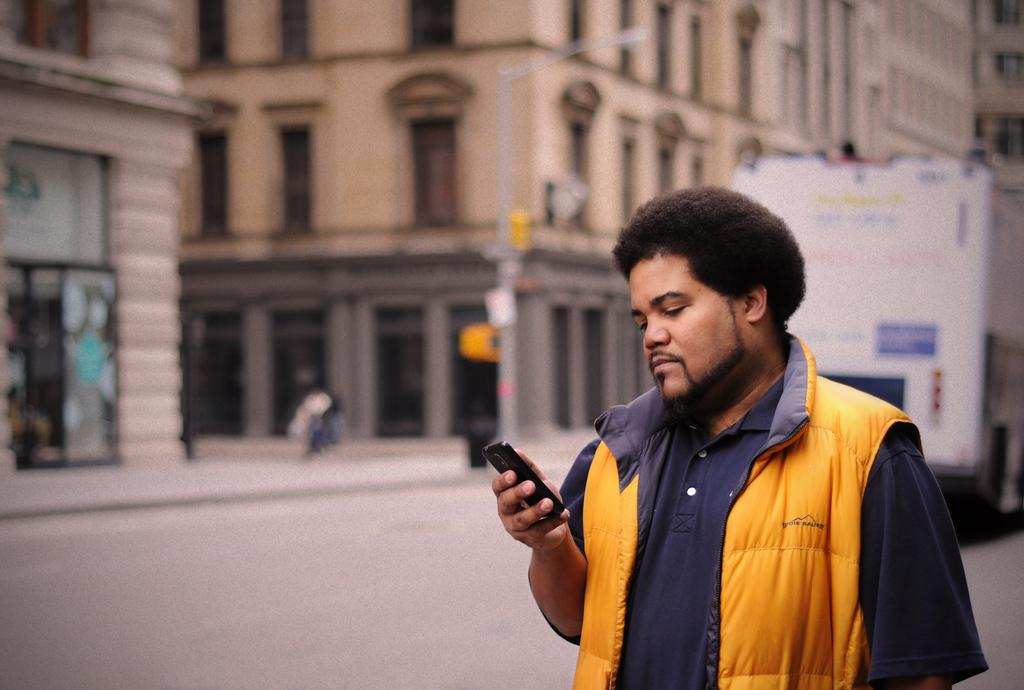What is the main subject of the image? There is a person in the image. What is the person holding in the image? The person is holding a mobile. Can you describe the person's clothing in the image? The person is wearing a blue and yellow color dress. What can be seen in the background of the image? There are buildings, a light pole, and a vehicle in the background of the image. What type of patch is sewn onto the dress in the image? There is no patch visible on the dress in the image. How does the person feel about the situation in the image? The image does not provide any information about the person's feelings or emotions. 